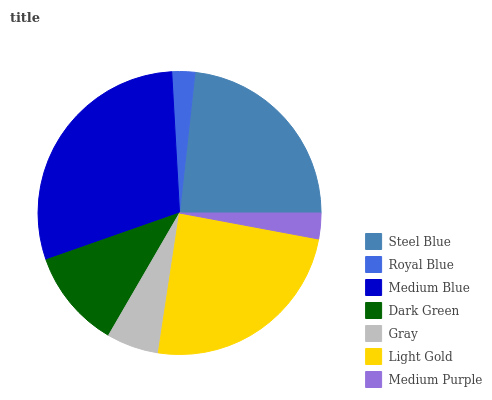Is Royal Blue the minimum?
Answer yes or no. Yes. Is Medium Blue the maximum?
Answer yes or no. Yes. Is Medium Blue the minimum?
Answer yes or no. No. Is Royal Blue the maximum?
Answer yes or no. No. Is Medium Blue greater than Royal Blue?
Answer yes or no. Yes. Is Royal Blue less than Medium Blue?
Answer yes or no. Yes. Is Royal Blue greater than Medium Blue?
Answer yes or no. No. Is Medium Blue less than Royal Blue?
Answer yes or no. No. Is Dark Green the high median?
Answer yes or no. Yes. Is Dark Green the low median?
Answer yes or no. Yes. Is Steel Blue the high median?
Answer yes or no. No. Is Steel Blue the low median?
Answer yes or no. No. 